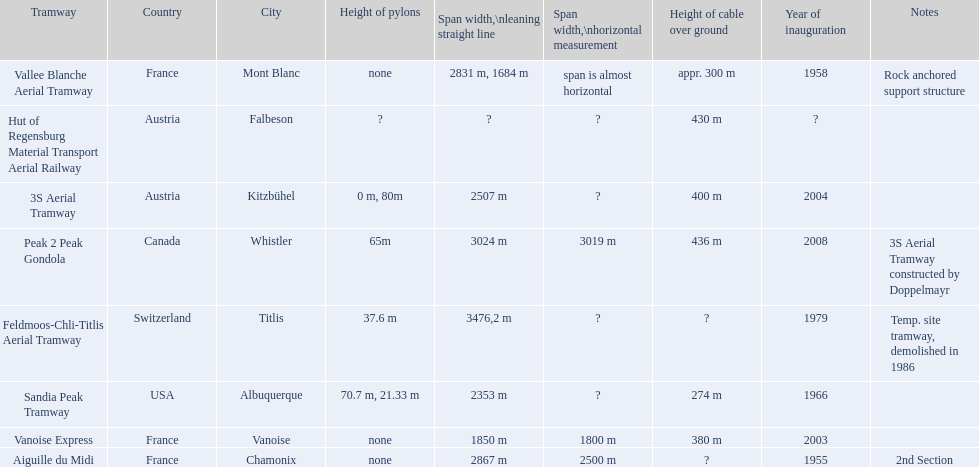When was the aiguille du midi tramway inaugurated? 1955. When was the 3s aerial tramway inaugurated? 2004. Which one was inaugurated first? Aiguille du Midi. 